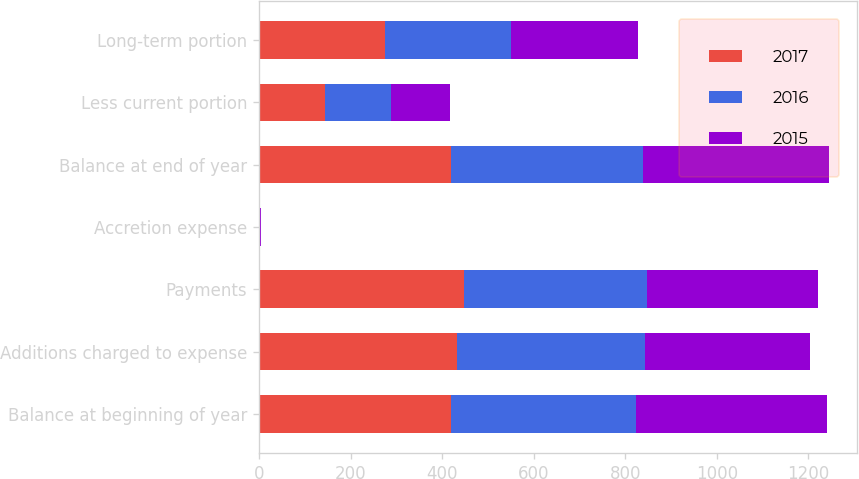<chart> <loc_0><loc_0><loc_500><loc_500><stacked_bar_chart><ecel><fcel>Balance at beginning of year<fcel>Additions charged to expense<fcel>Payments<fcel>Accretion expense<fcel>Balance at end of year<fcel>Less current portion<fcel>Long-term portion<nl><fcel>2017<fcel>418.5<fcel>432.9<fcel>448<fcel>1.2<fcel>420.2<fcel>144.8<fcel>275.4<nl><fcel>2016<fcel>405.8<fcel>410.3<fcel>400.5<fcel>1.5<fcel>418.5<fcel>143.9<fcel>274.6<nl><fcel>2015<fcel>416.6<fcel>360.4<fcel>373.1<fcel>1.9<fcel>405.8<fcel>127.7<fcel>278.1<nl></chart> 